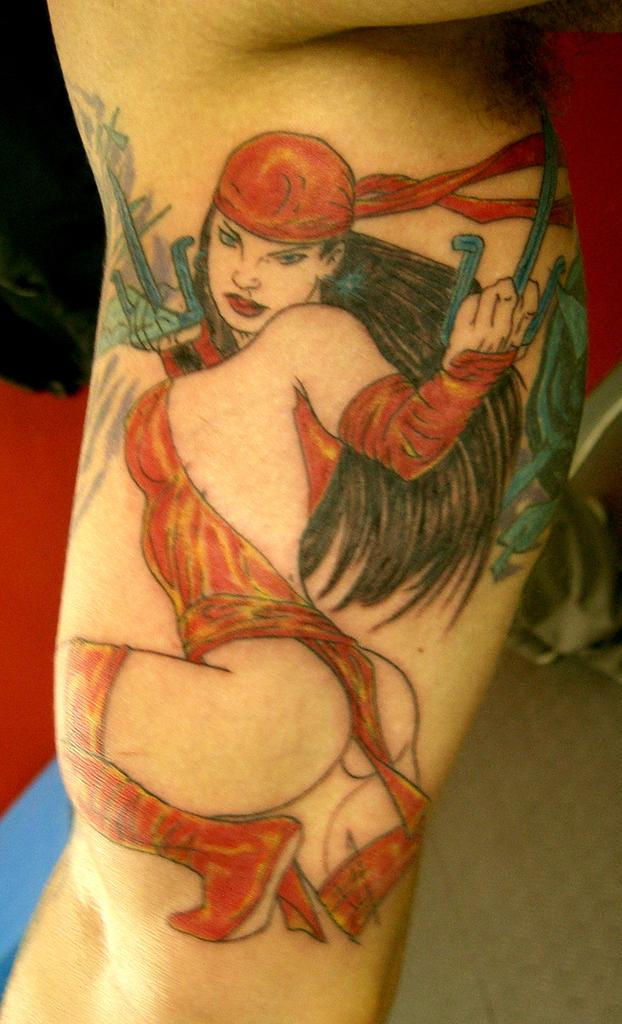What is the main subject of the image? The main subject of the image is the hand of a person. Can you describe the hand in the image? The hand has a tattoo. What else can be seen in the image besides the hand? There are objects visible in the background of the image. What type of apple is being held by the hand in the image? There is no apple present in the image; the hand has a tattoo and is surrounded by objects in the background. 